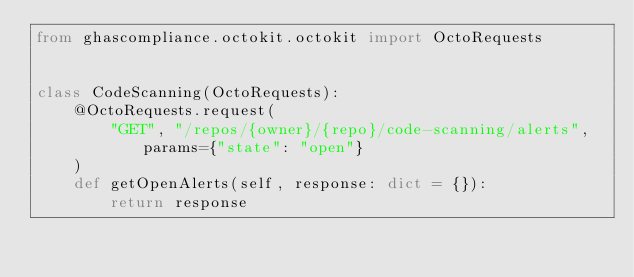<code> <loc_0><loc_0><loc_500><loc_500><_Python_>from ghascompliance.octokit.octokit import OctoRequests


class CodeScanning(OctoRequests):
    @OctoRequests.request(
        "GET", "/repos/{owner}/{repo}/code-scanning/alerts", params={"state": "open"}
    )
    def getOpenAlerts(self, response: dict = {}):
        return response
</code> 